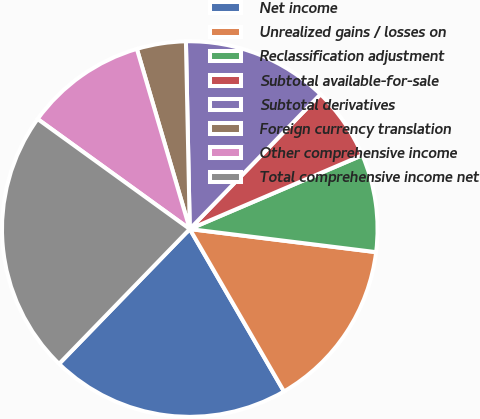Convert chart to OTSL. <chart><loc_0><loc_0><loc_500><loc_500><pie_chart><fcel>Net income<fcel>Unrealized gains / losses on<fcel>Reclassification adjustment<fcel>Subtotal available-for-sale<fcel>Subtotal derivatives<fcel>Foreign currency translation<fcel>Other comprehensive income<fcel>Total comprehensive income net<nl><fcel>20.62%<fcel>14.67%<fcel>8.4%<fcel>6.31%<fcel>12.58%<fcel>4.22%<fcel>10.49%<fcel>22.71%<nl></chart> 